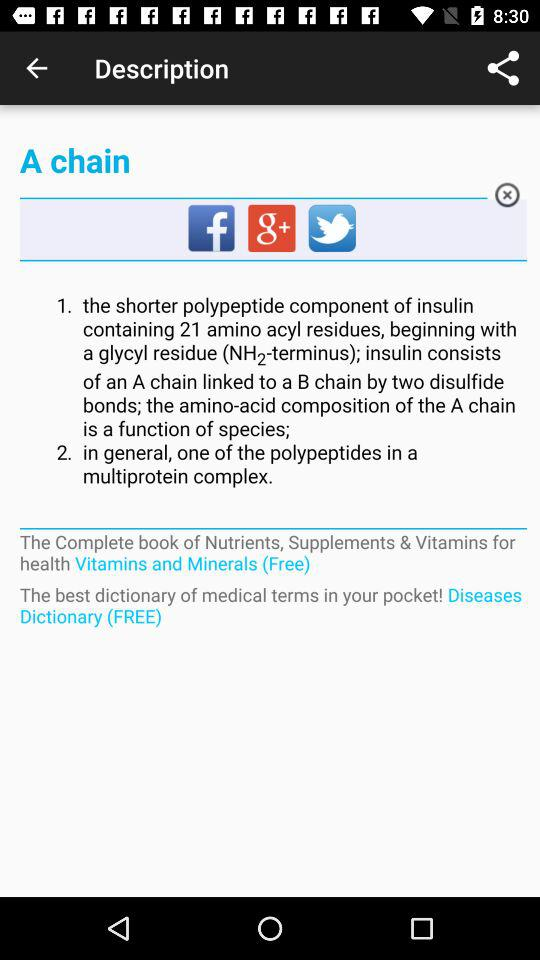How many amino acyl residues are contained in a polypeptide? There are 21 amino acyl residues contained in a polypeptide. 